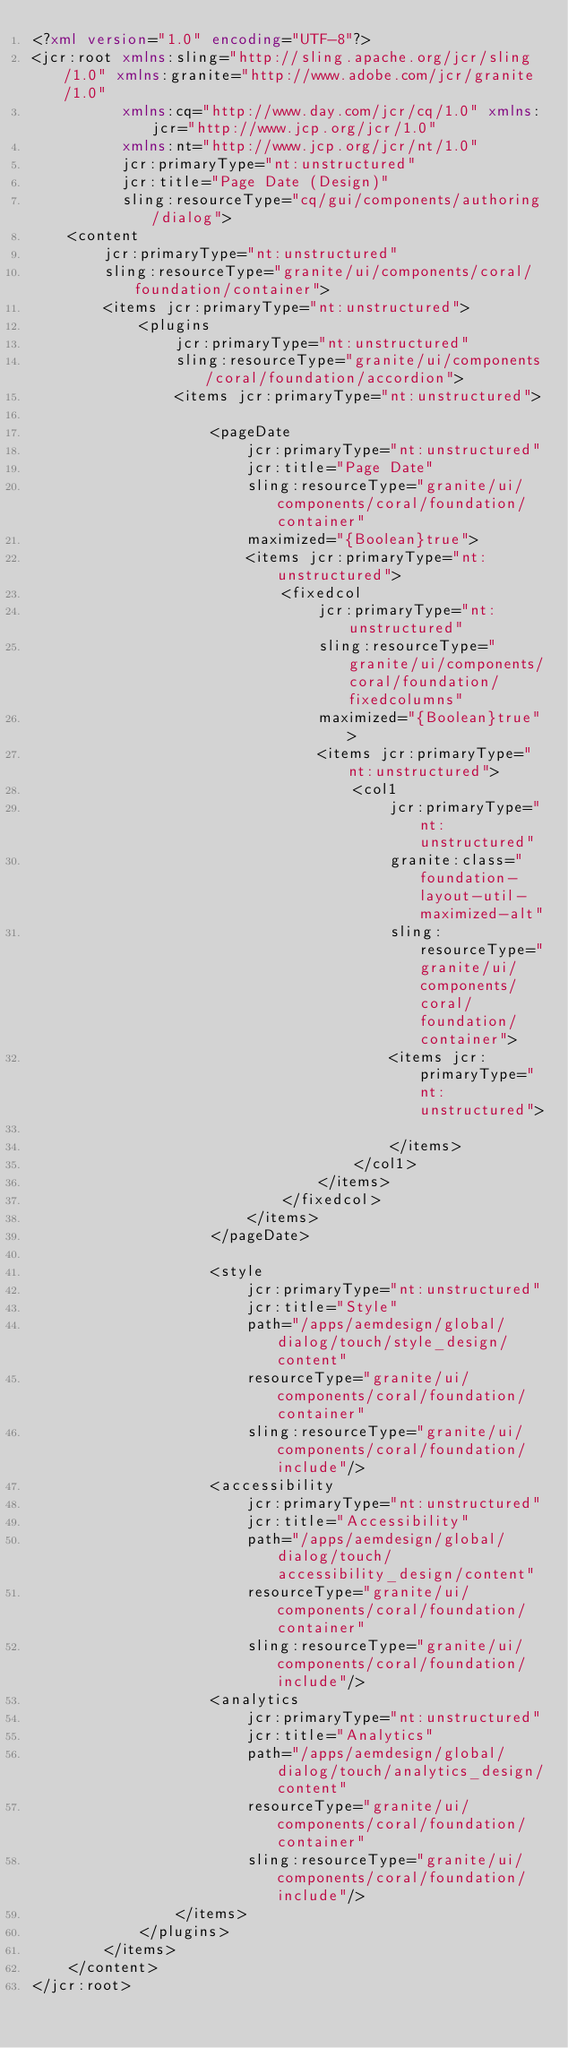Convert code to text. <code><loc_0><loc_0><loc_500><loc_500><_XML_><?xml version="1.0" encoding="UTF-8"?>
<jcr:root xmlns:sling="http://sling.apache.org/jcr/sling/1.0" xmlns:granite="http://www.adobe.com/jcr/granite/1.0"
          xmlns:cq="http://www.day.com/jcr/cq/1.0" xmlns:jcr="http://www.jcp.org/jcr/1.0"
          xmlns:nt="http://www.jcp.org/jcr/nt/1.0"
          jcr:primaryType="nt:unstructured"
          jcr:title="Page Date (Design)"
          sling:resourceType="cq/gui/components/authoring/dialog">
    <content
        jcr:primaryType="nt:unstructured"
        sling:resourceType="granite/ui/components/coral/foundation/container">
        <items jcr:primaryType="nt:unstructured">
            <plugins
                jcr:primaryType="nt:unstructured"
                sling:resourceType="granite/ui/components/coral/foundation/accordion">
                <items jcr:primaryType="nt:unstructured">

                    <pageDate
                        jcr:primaryType="nt:unstructured"
                        jcr:title="Page Date"
                        sling:resourceType="granite/ui/components/coral/foundation/container"
                        maximized="{Boolean}true">
                        <items jcr:primaryType="nt:unstructured">
                            <fixedcol
                                jcr:primaryType="nt:unstructured"
                                sling:resourceType="granite/ui/components/coral/foundation/fixedcolumns"
                                maximized="{Boolean}true">
                                <items jcr:primaryType="nt:unstructured">
                                    <col1
                                        jcr:primaryType="nt:unstructured"
                                        granite:class="foundation-layout-util-maximized-alt"
                                        sling:resourceType="granite/ui/components/coral/foundation/container">
                                        <items jcr:primaryType="nt:unstructured">

                                        </items>
                                    </col1>
                                </items>
                            </fixedcol>
                        </items>
                    </pageDate>

                    <style
                        jcr:primaryType="nt:unstructured"
                        jcr:title="Style"
                        path="/apps/aemdesign/global/dialog/touch/style_design/content"
                        resourceType="granite/ui/components/coral/foundation/container"
                        sling:resourceType="granite/ui/components/coral/foundation/include"/>
                    <accessibility
                        jcr:primaryType="nt:unstructured"
                        jcr:title="Accessibility"
                        path="/apps/aemdesign/global/dialog/touch/accessibility_design/content"
                        resourceType="granite/ui/components/coral/foundation/container"
                        sling:resourceType="granite/ui/components/coral/foundation/include"/>
                    <analytics
                        jcr:primaryType="nt:unstructured"
                        jcr:title="Analytics"
                        path="/apps/aemdesign/global/dialog/touch/analytics_design/content"
                        resourceType="granite/ui/components/coral/foundation/container"
                        sling:resourceType="granite/ui/components/coral/foundation/include"/>
                </items>
            </plugins>
        </items>
    </content>
</jcr:root>
</code> 